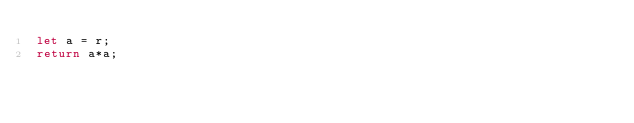<code> <loc_0><loc_0><loc_500><loc_500><_JavaScript_>let a = r;
return a*a;</code> 